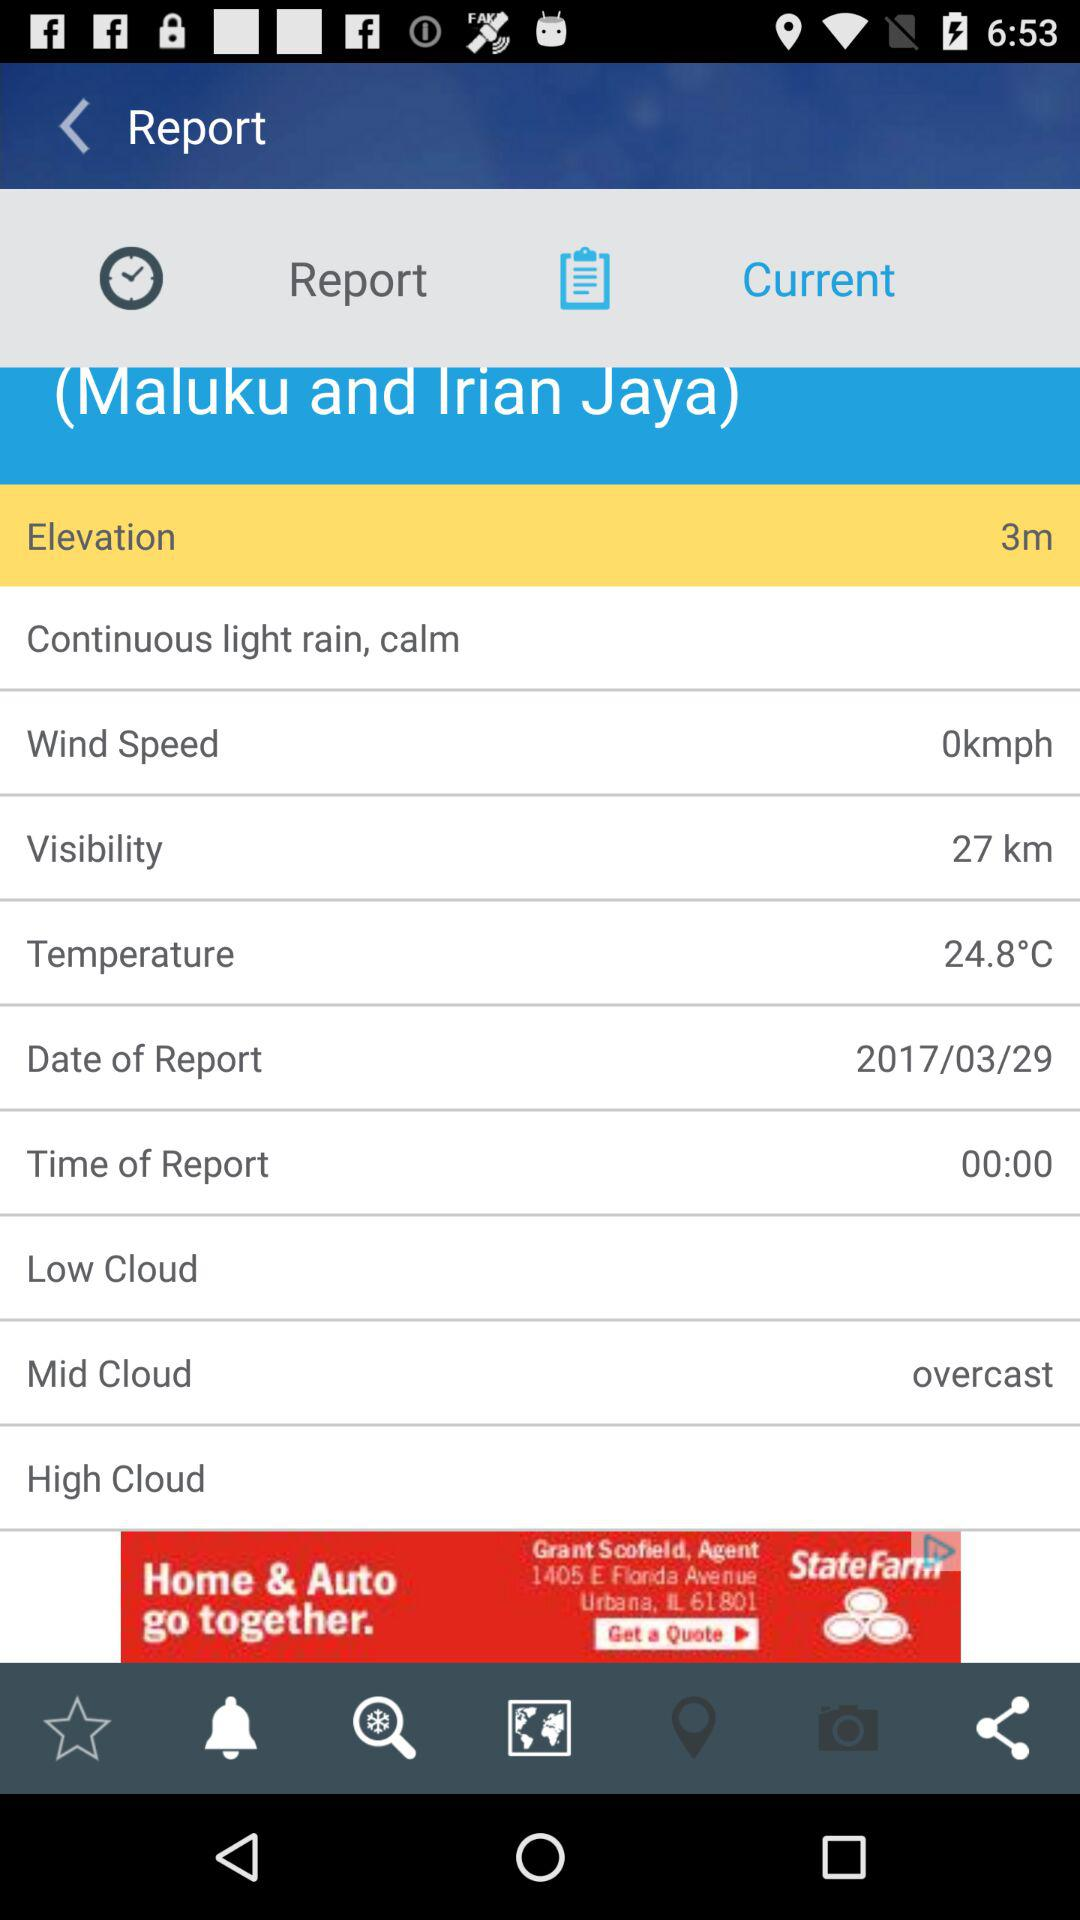What is the temperature? The temperature is 24.8 °C. 